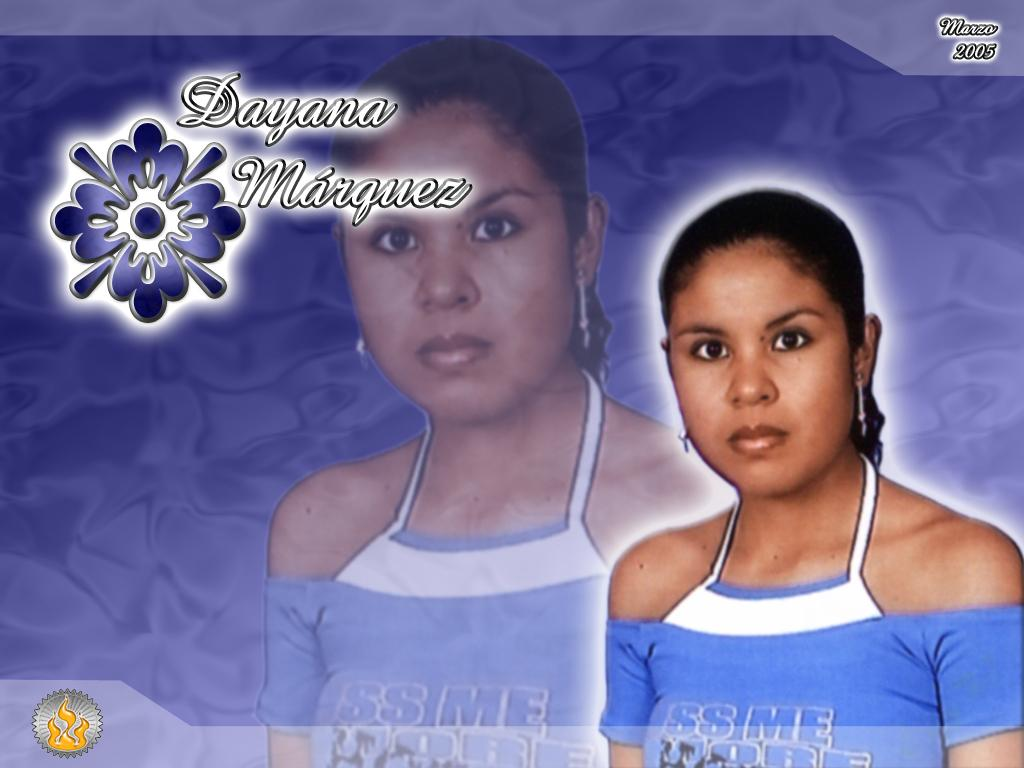<image>
Present a compact description of the photo's key features. The lady pictured in blue is called Dayana Marquez. 